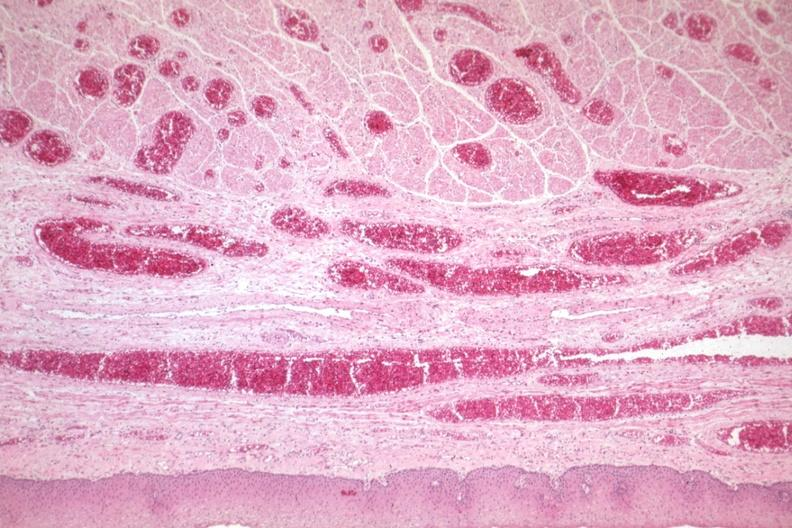what does this image show?
Answer the question using a single word or phrase. Good example of veins filled with blood 